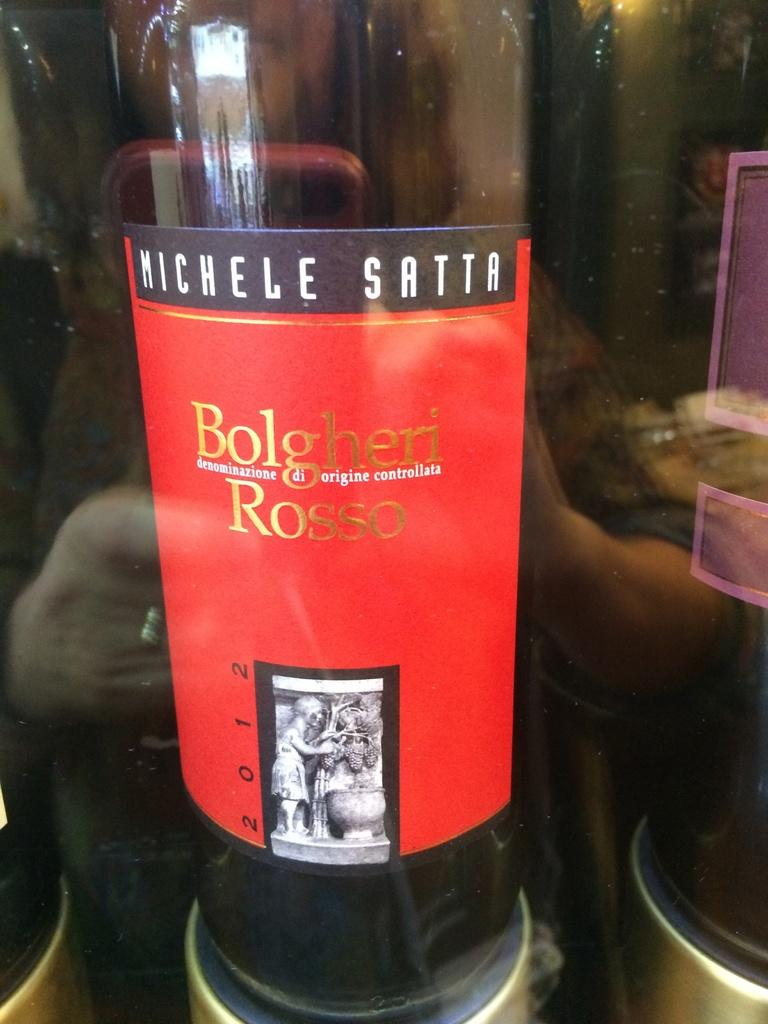<image>
Relay a brief, clear account of the picture shown. bottle of wine called bolgheri rosse from 2012 